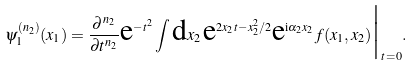Convert formula to latex. <formula><loc_0><loc_0><loc_500><loc_500>\psi _ { 1 } ^ { ( n _ { 2 } ) } ( x _ { 1 } ) = \frac { \partial ^ { n _ { 2 } } } { \partial t ^ { n _ { 2 } } } \text {e} ^ { - t ^ { 2 } } \int \text {d} x _ { 2 } \, \text {e} ^ { 2 x _ { 2 } t - x _ { 2 } ^ { 2 } / 2 } \text {e} ^ { \text {i} \alpha _ { 2 } x _ { 2 } } f ( x _ { 1 } , x _ { 2 } ) \Big | _ { t = 0 } .</formula> 